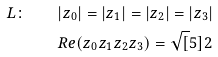<formula> <loc_0><loc_0><loc_500><loc_500>L \colon \quad & | z _ { 0 } | = | z _ { 1 } | = | z _ { 2 } | = | z _ { 3 } | \\ & R e ( z _ { 0 } z _ { 1 } z _ { 2 } z _ { 3 } ) = \sqrt { [ } 5 ] { 2 }</formula> 